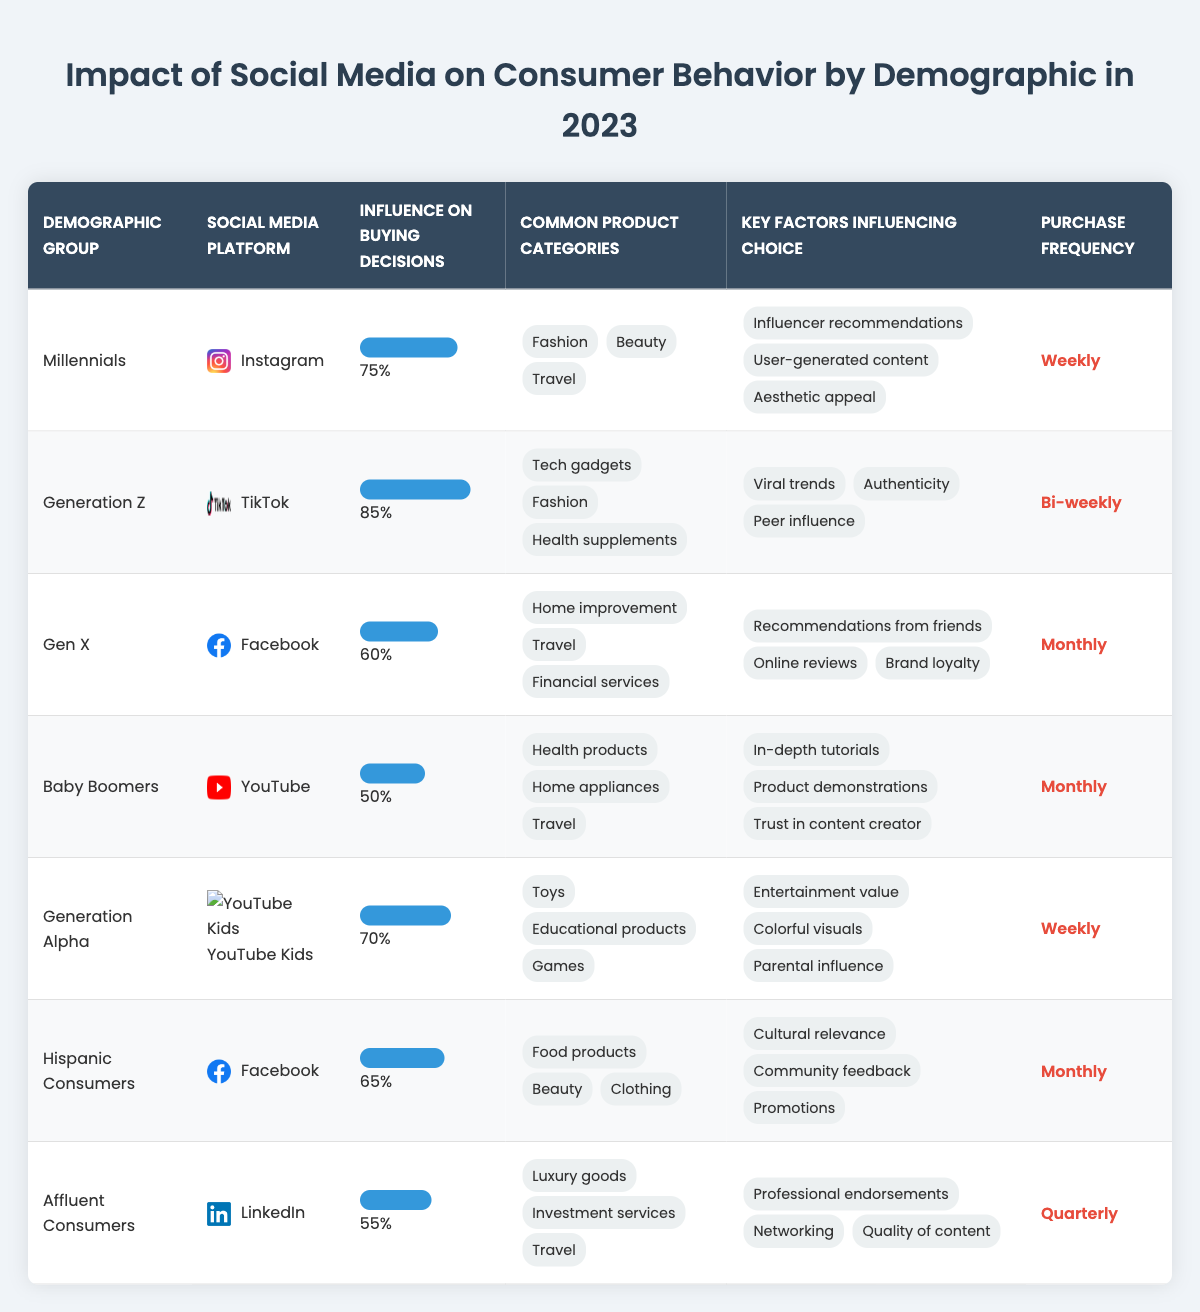What is the most influential social media platform for Generation Z? According to the table, Generation Z uses TikTok as their primary social media platform, which has an influence on buying decisions of 85%.
Answer: TikTok How frequently do Millennials make purchases influenced by social media? The purchase frequency for Millennials is stated as "Weekly," indicating they frequently buy influenced by social media.
Answer: Weekly What are the common product categories for Baby Boomers? The table lists three common product categories for Baby Boomers: Health products, Home appliances, and Travel.
Answer: Health products, Home appliances, Travel Which demographic group has the lowest influence on buying decisions from social media? By examining the influence percentages, Baby Boomers have the lowest at 50%.
Answer: Baby Boomers What is the influence percentage of social media on buying decisions for Hispanic Consumers? The table shows that social media influences buying decisions for Hispanic Consumers by 65%.
Answer: 65% What is the average influence percentage of all demographic groups listed in the table? The influence percentages are 75%, 85%, 60%, 50%, 70%, 65%, and 55%, totaling to 60%/7, which is approximately 64.3%.
Answer: 64.3% Do Affluent Consumers make purchases more frequently than Generation Z? The frequency for Affluent Consumers is "Quarterly," while for Generation Z it is "Bi-weekly," indicating that Generation Z makes purchases more often.
Answer: No Which demographic has more influence from user-generated content, Millennials or Generation Alpha? Millennials show a key factor of "User-generated content" while for Generation Alpha, the key factors included "Parental influence" and "Entertainment value." Thus, Millennials have more influence from user-generated content.
Answer: Millennials How many different social media platforms are represented in the table? The table lists Instagram, TikTok, Facebook, YouTube, YouTube Kids, and LinkedIn, making a total of 6 different platforms.
Answer: 6 